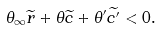Convert formula to latex. <formula><loc_0><loc_0><loc_500><loc_500>\theta _ { \infty } \widetilde { r } + \theta \widetilde { c } + \theta ^ { \prime } \widetilde { c ^ { \prime } } < 0 .</formula> 